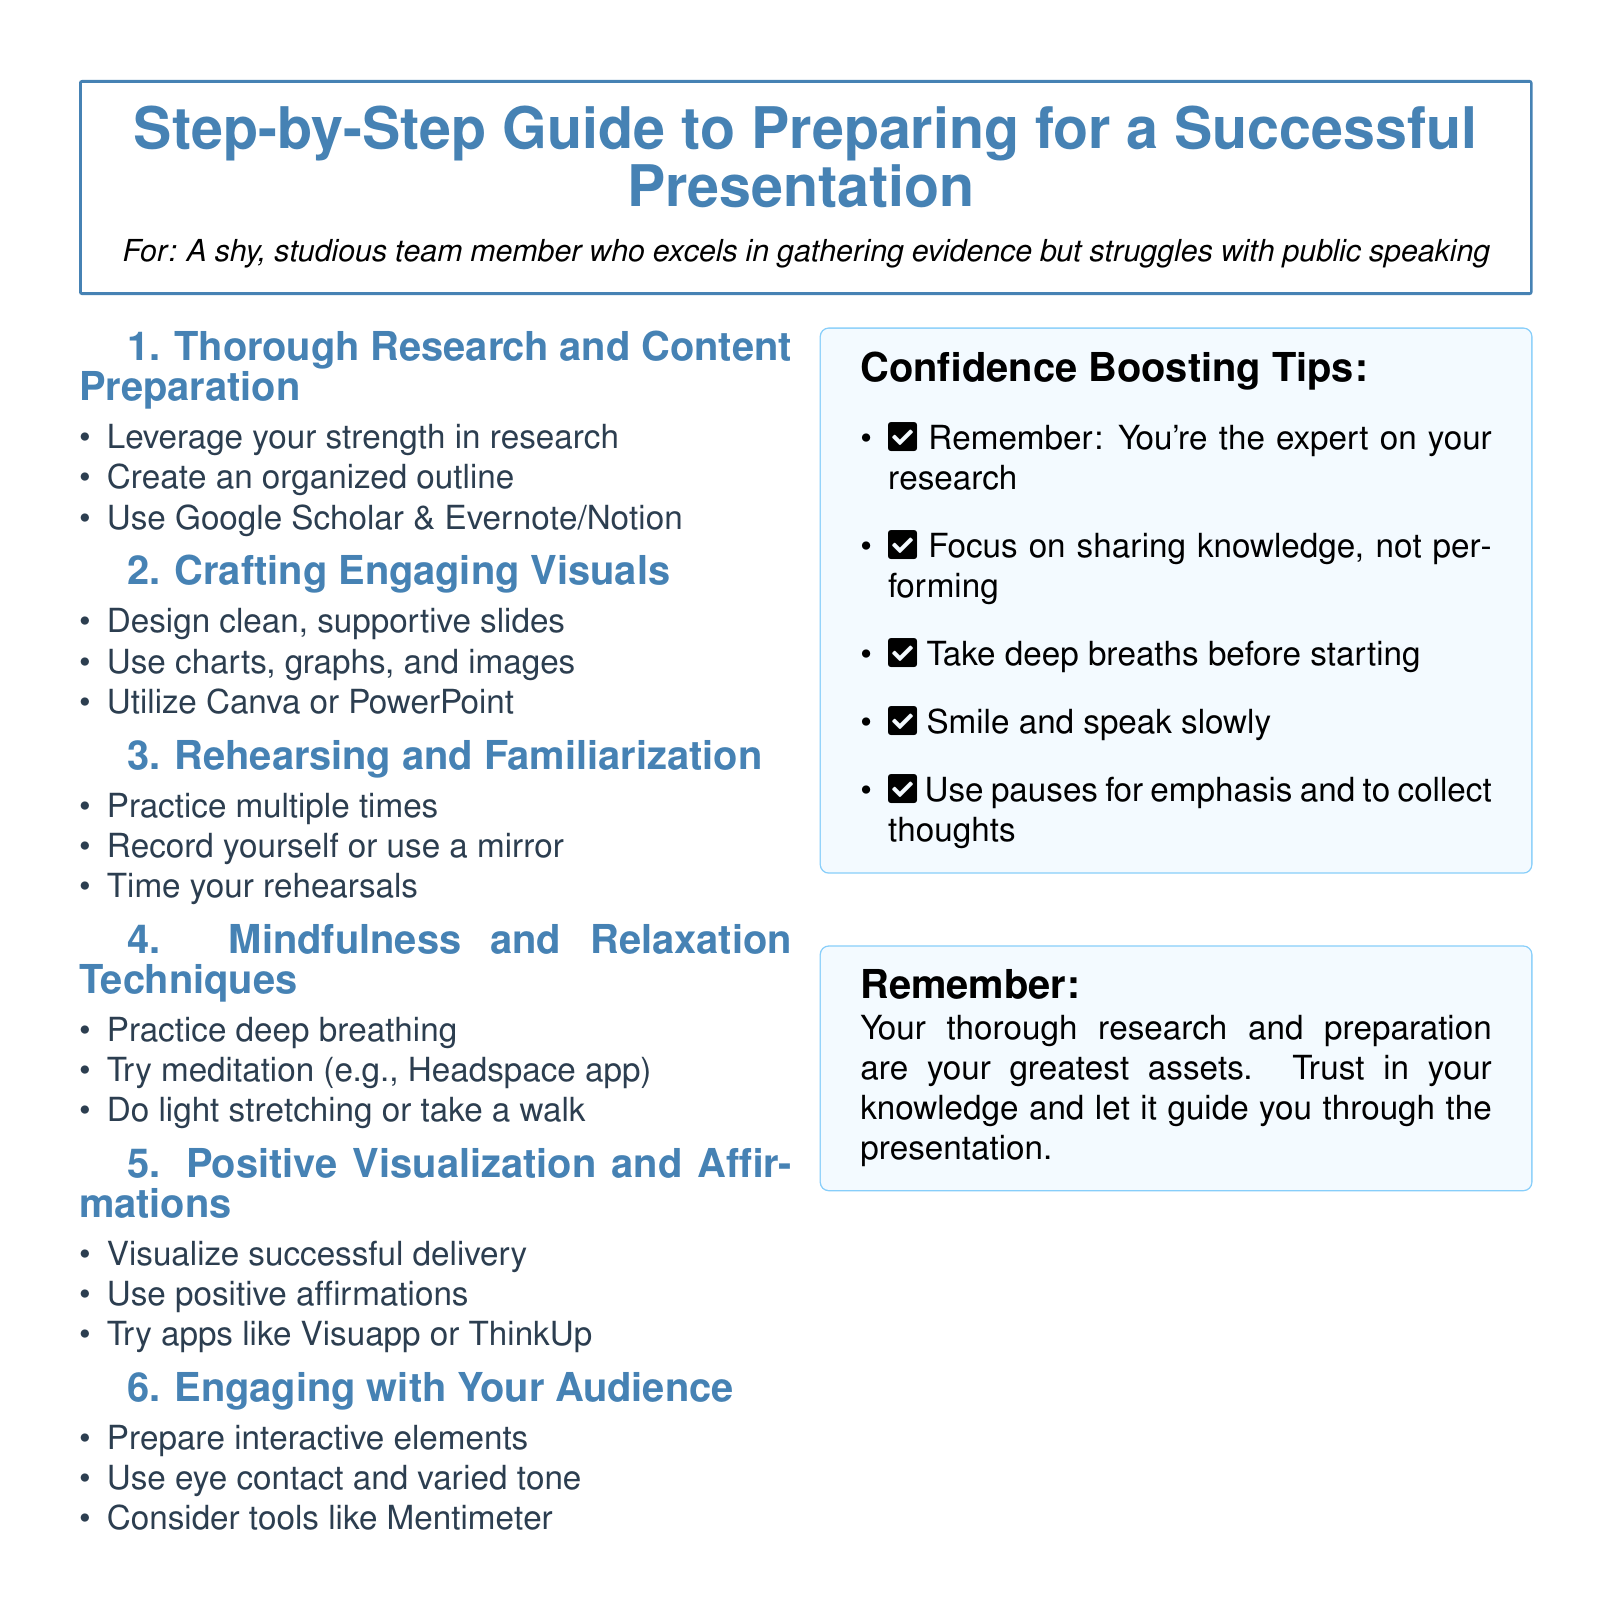What is the title of the document? The title is prominently displayed at the top of the document, summarizing its main focus.
Answer: Step-by-Step Guide to Preparing for a Successful Presentation What is the first step listed in preparing for a presentation? The first step outlines specific actions to be taken for effective preparation.
Answer: Thorough Research and Content Preparation Which app is suggested for practicing meditation? The document mentions tools for mindfulness and relaxation techniques, including specific apps.
Answer: Headspace What is one confidence-boosting tip mentioned? The tips for boosting confidence are helpful for public speaking and are clearly outlined.
Answer: Smile and speak slowly How many steps are there in total for preparing a presentation? Counting the listed steps will give the total number included in the guide.
Answer: Six What visual aids are recommended for engaging presentations? The document emphasizes the importance of visuals while presenting and suggests types of aids to use.
Answer: Charts, graphs, and images Which tool is suggested for checking audience engagement? Specific tools are highlighted for interacting with the audience during the presentation.
Answer: Mentimeter What is mentioned as your greatest asset for the presentation? The document concludes with a reminder of an important aspect that contributes to successful presentations.
Answer: Thorough research and preparation 